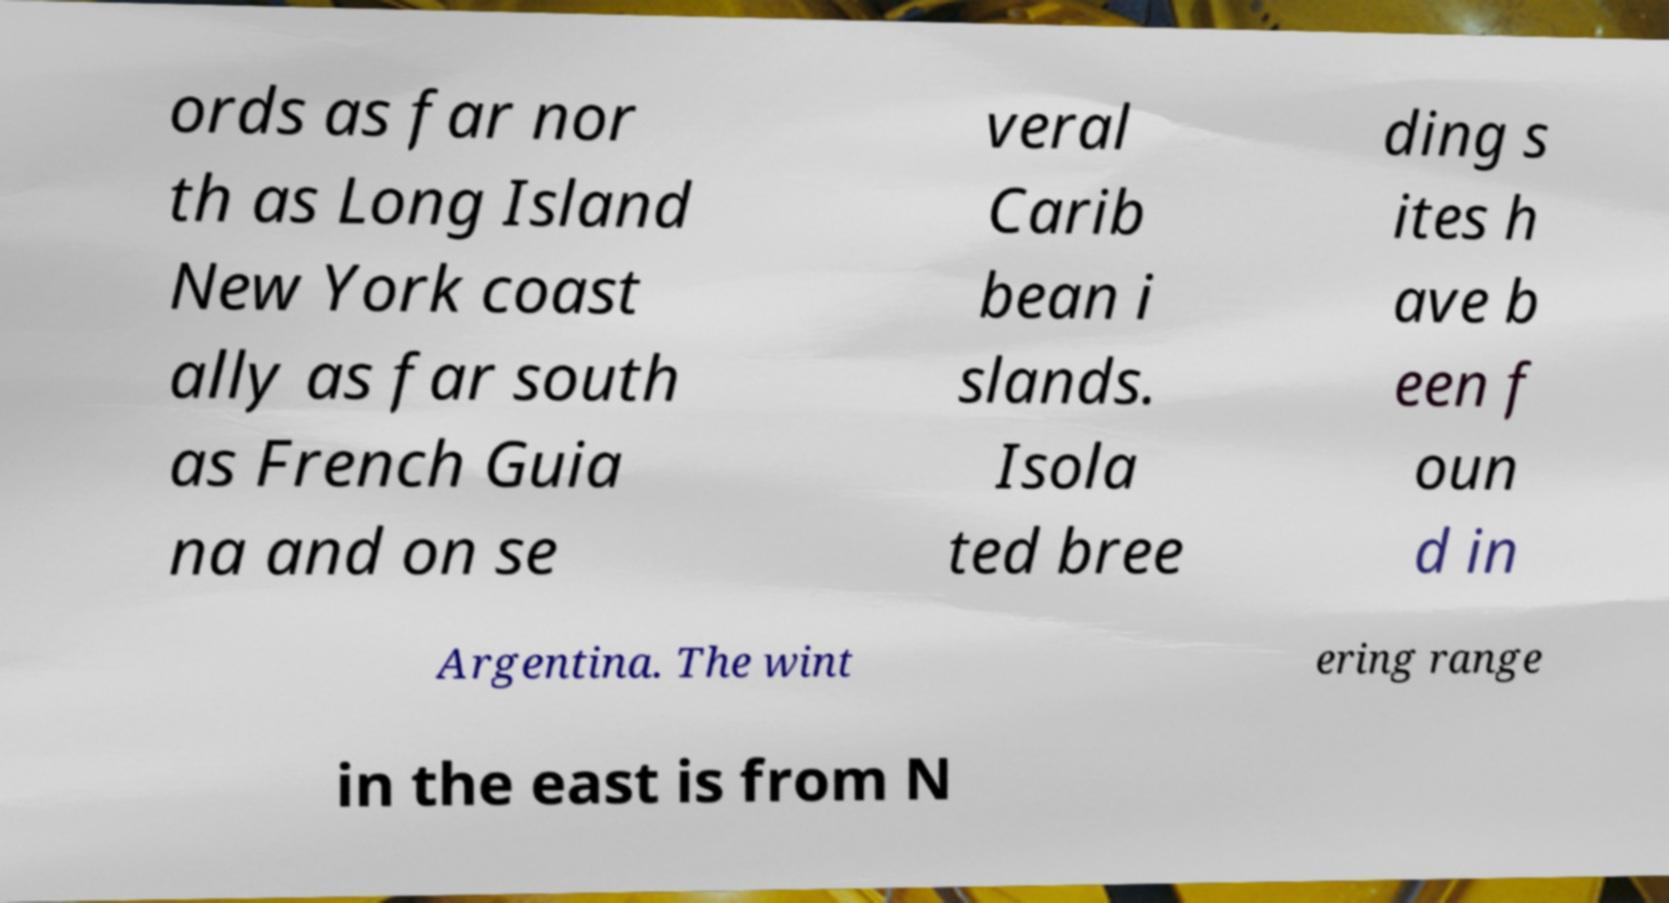Please read and relay the text visible in this image. What does it say? ords as far nor th as Long Island New York coast ally as far south as French Guia na and on se veral Carib bean i slands. Isola ted bree ding s ites h ave b een f oun d in Argentina. The wint ering range in the east is from N 